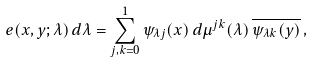<formula> <loc_0><loc_0><loc_500><loc_500>e ( x , y ; \lambda ) \, d \lambda = \sum _ { j , k = 0 } ^ { 1 } \psi _ { \lambda j } ( x ) \, d \mu ^ { j k } ( \lambda ) \, \overline { \psi _ { \lambda k } ( y ) } \, ,</formula> 